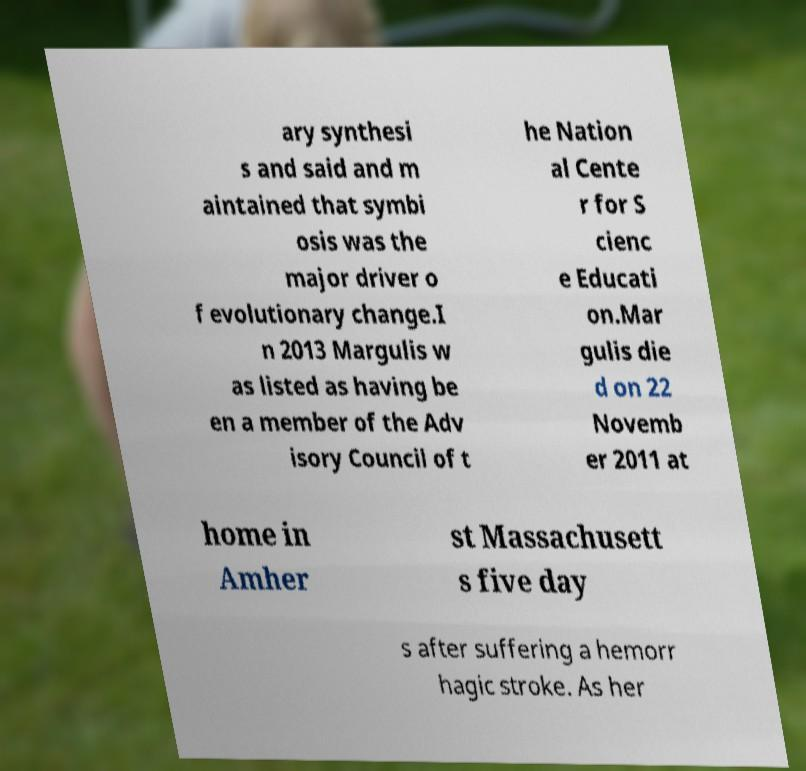For documentation purposes, I need the text within this image transcribed. Could you provide that? ary synthesi s and said and m aintained that symbi osis was the major driver o f evolutionary change.I n 2013 Margulis w as listed as having be en a member of the Adv isory Council of t he Nation al Cente r for S cienc e Educati on.Mar gulis die d on 22 Novemb er 2011 at home in Amher st Massachusett s five day s after suffering a hemorr hagic stroke. As her 